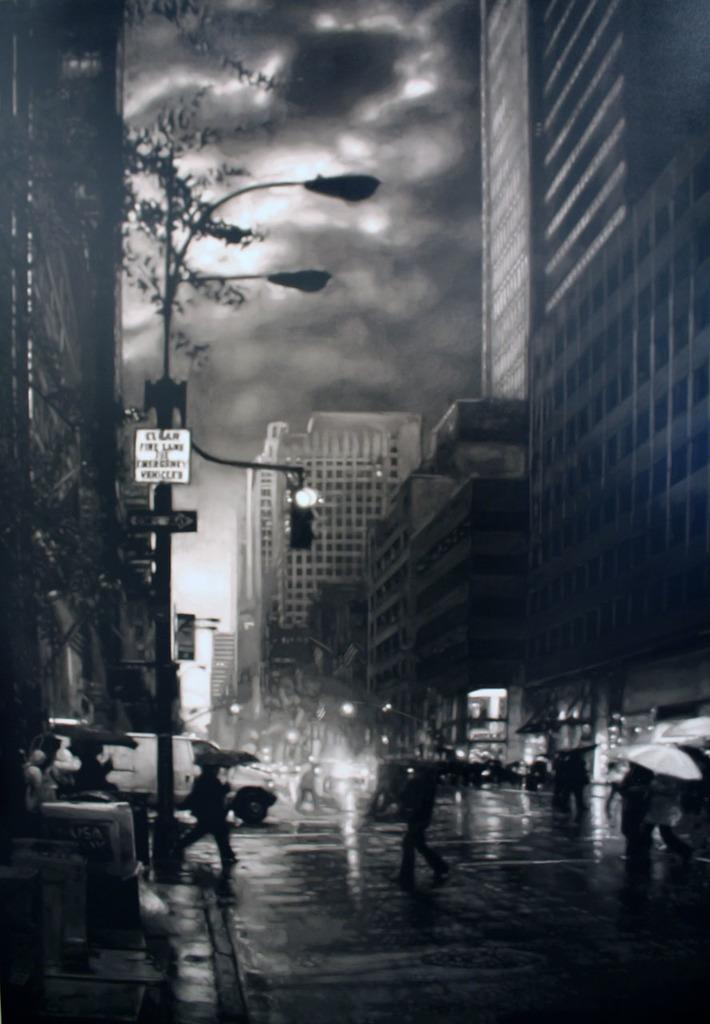What is the condition of the sky in the image? The sky is cloudy in the image. What type of structures can be seen in the image? There are buildings in the image. What are the tall, vertical objects in the image? Light poles are present in the image. What type of information is displayed on the vertical objects in the image? Signboards are visible in the image. What are the people in the image using to protect themselves from the weather? People are holding umbrellas in the image. What type of advice can be seen on the feast in the image? There is no feast present in the image, and therefore no advice can be seen on it. What type of flight is depicted in the image? There is no flight depicted in the image. 